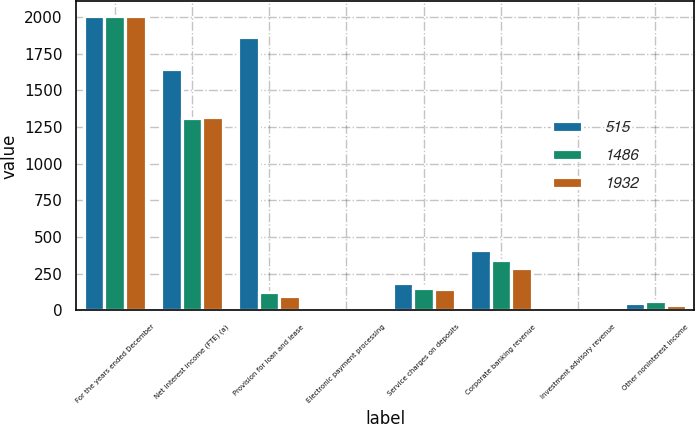<chart> <loc_0><loc_0><loc_500><loc_500><stacked_bar_chart><ecel><fcel>For the years ended December<fcel>Net interest income (FTE) (a)<fcel>Provision for loan and lease<fcel>Electronic payment processing<fcel>Service charges on deposits<fcel>Corporate banking revenue<fcel>Investment advisory revenue<fcel>Other noninterest income<nl><fcel>515<fcel>2008<fcel>1645<fcel>1864<fcel>2<fcel>186<fcel>414<fcel>5<fcel>52<nl><fcel>1486<fcel>2007<fcel>1311<fcel>127<fcel>6<fcel>154<fcel>341<fcel>3<fcel>66<nl><fcel>1932<fcel>2006<fcel>1318<fcel>99<fcel>5<fcel>146<fcel>292<fcel>3<fcel>40<nl></chart> 